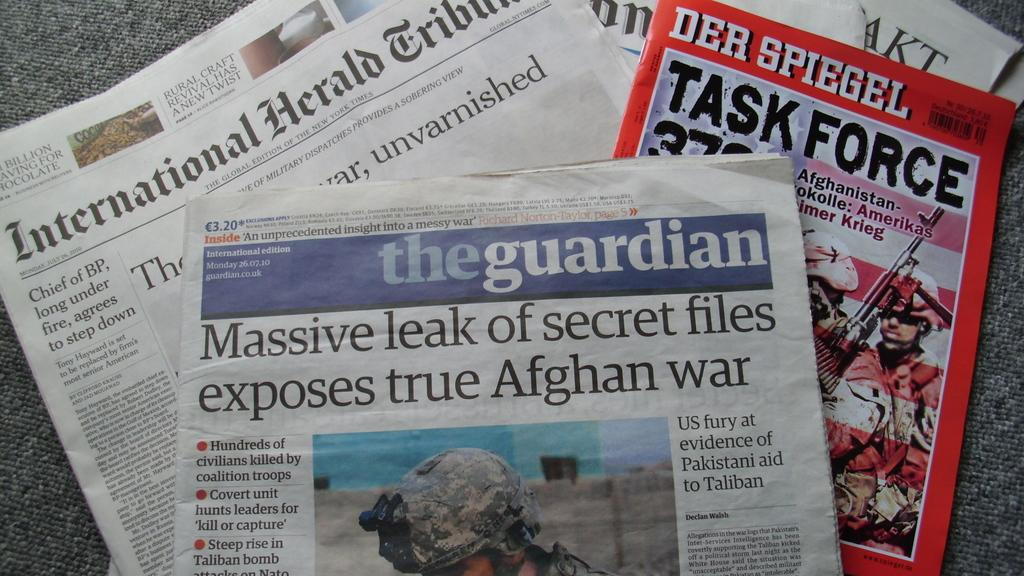What type of reading material is present in the image? There are newspapers in the image. What color is the book in the image? There is a red book in the image. Where are the newspapers and the red book located? The newspapers and the red book are on a surface. How many bubbles are floating around the newspapers in the image? There are no bubbles present in the image; it only features newspapers and a red book on a surface. 